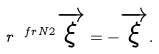<formula> <loc_0><loc_0><loc_500><loc_500>r ^ { \ f r { N } { 2 } } \overrightarrow { \xi } = - \overrightarrow { \xi } .</formula> 